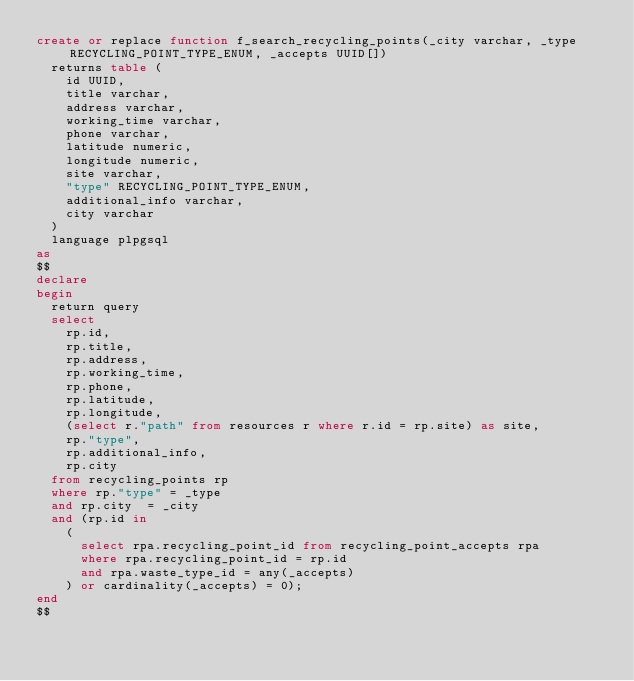<code> <loc_0><loc_0><loc_500><loc_500><_SQL_>create or replace function f_search_recycling_points(_city varchar, _type RECYCLING_POINT_TYPE_ENUM, _accepts UUID[])
	returns table (
		id UUID,
		title varchar,
		address varchar,
		working_time varchar,
		phone varchar,
		latitude numeric,
		longitude numeric,
		site varchar,
		"type" RECYCLING_POINT_TYPE_ENUM,
		additional_info varchar,
		city varchar
	)
	language plpgsql
as
$$
declare
begin
	return query
	select
		rp.id,
		rp.title,
		rp.address,
		rp.working_time,
		rp.phone,
		rp.latitude,
		rp.longitude,
		(select r."path" from resources r where r.id = rp.site) as site,
		rp."type",
		rp.additional_info,
		rp.city
	from recycling_points rp
	where rp."type" = _type
	and rp.city  = _city
	and (rp.id in 
		(
			select rpa.recycling_point_id from recycling_point_accepts rpa
			where rpa.recycling_point_id = rp.id
			and rpa.waste_type_id = any(_accepts)
		) or cardinality(_accepts) = 0);
end
$$

</code> 